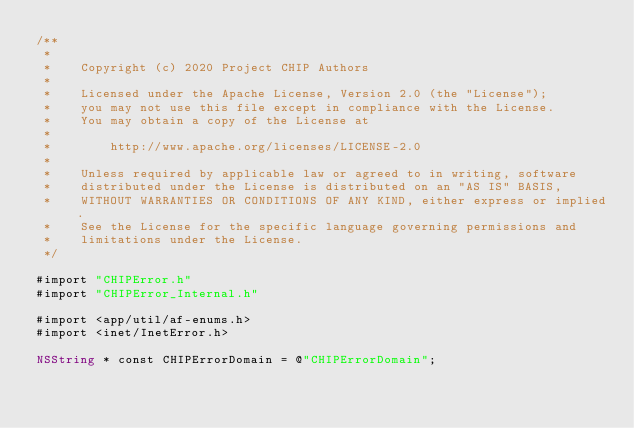Convert code to text. <code><loc_0><loc_0><loc_500><loc_500><_ObjectiveC_>/**
 *
 *    Copyright (c) 2020 Project CHIP Authors
 *
 *    Licensed under the Apache License, Version 2.0 (the "License");
 *    you may not use this file except in compliance with the License.
 *    You may obtain a copy of the License at
 *
 *        http://www.apache.org/licenses/LICENSE-2.0
 *
 *    Unless required by applicable law or agreed to in writing, software
 *    distributed under the License is distributed on an "AS IS" BASIS,
 *    WITHOUT WARRANTIES OR CONDITIONS OF ANY KIND, either express or implied.
 *    See the License for the specific language governing permissions and
 *    limitations under the License.
 */

#import "CHIPError.h"
#import "CHIPError_Internal.h"

#import <app/util/af-enums.h>
#import <inet/InetError.h>

NSString * const CHIPErrorDomain = @"CHIPErrorDomain";
</code> 